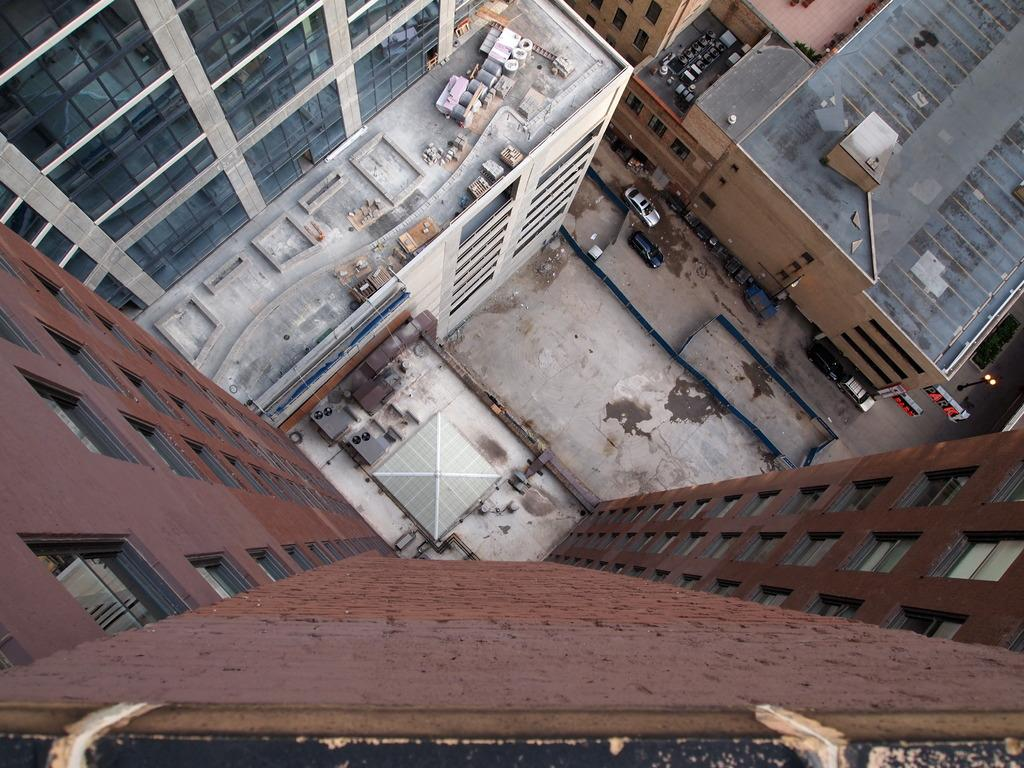What type of structures can be seen in the image? There are buildings in the image. What mode of transportation can be seen on the road in the image? There are two cars on the road in the image. What degree does the yard have in the image? There is no yard present in the image, so it is not possible to determine its degree. 